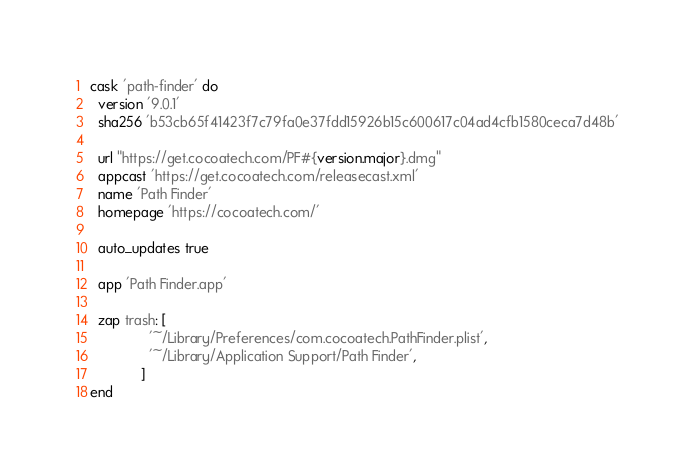<code> <loc_0><loc_0><loc_500><loc_500><_Ruby_>cask 'path-finder' do
  version '9.0.1'
  sha256 'b53cb65f41423f7c79fa0e37fdd15926b15c600617c04ad4cfb1580ceca7d48b'

  url "https://get.cocoatech.com/PF#{version.major}.dmg"
  appcast 'https://get.cocoatech.com/releasecast.xml'
  name 'Path Finder'
  homepage 'https://cocoatech.com/'

  auto_updates true

  app 'Path Finder.app'

  zap trash: [
               '~/Library/Preferences/com.cocoatech.PathFinder.plist',
               '~/Library/Application Support/Path Finder',
             ]
end
</code> 